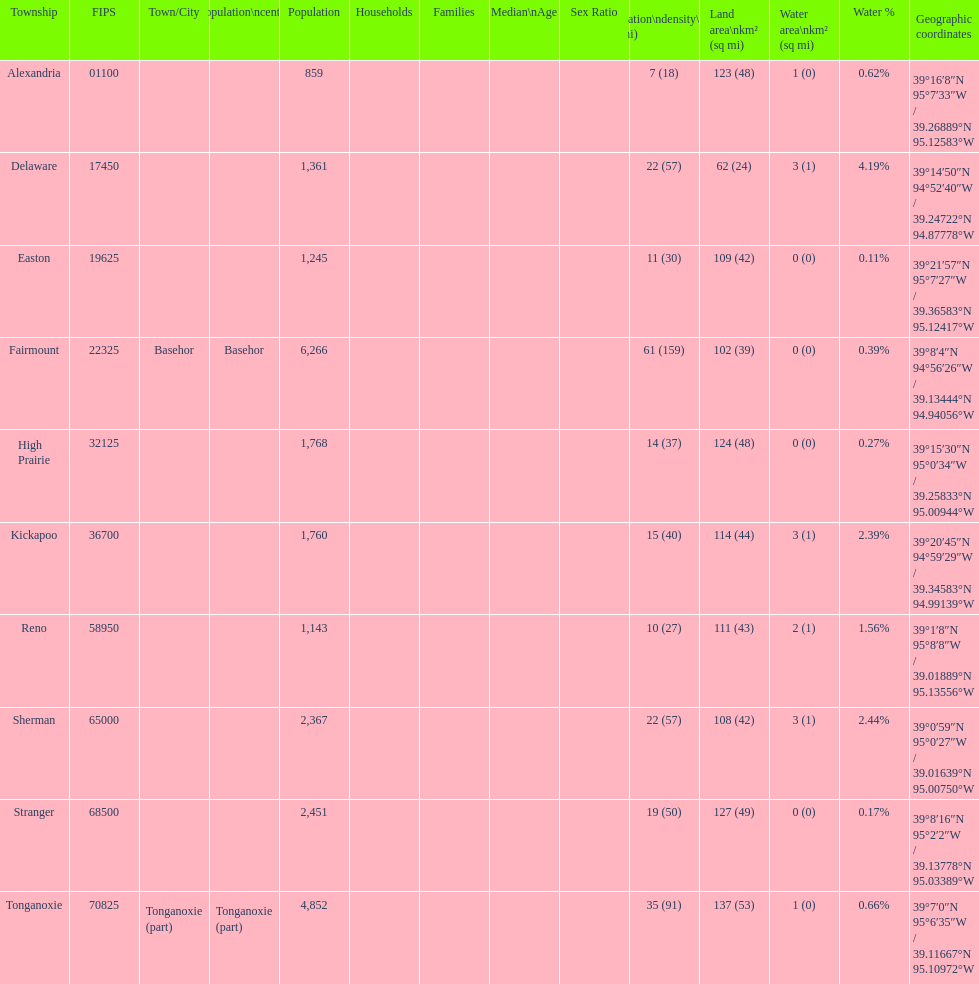What township has the most land area? Tonganoxie. 